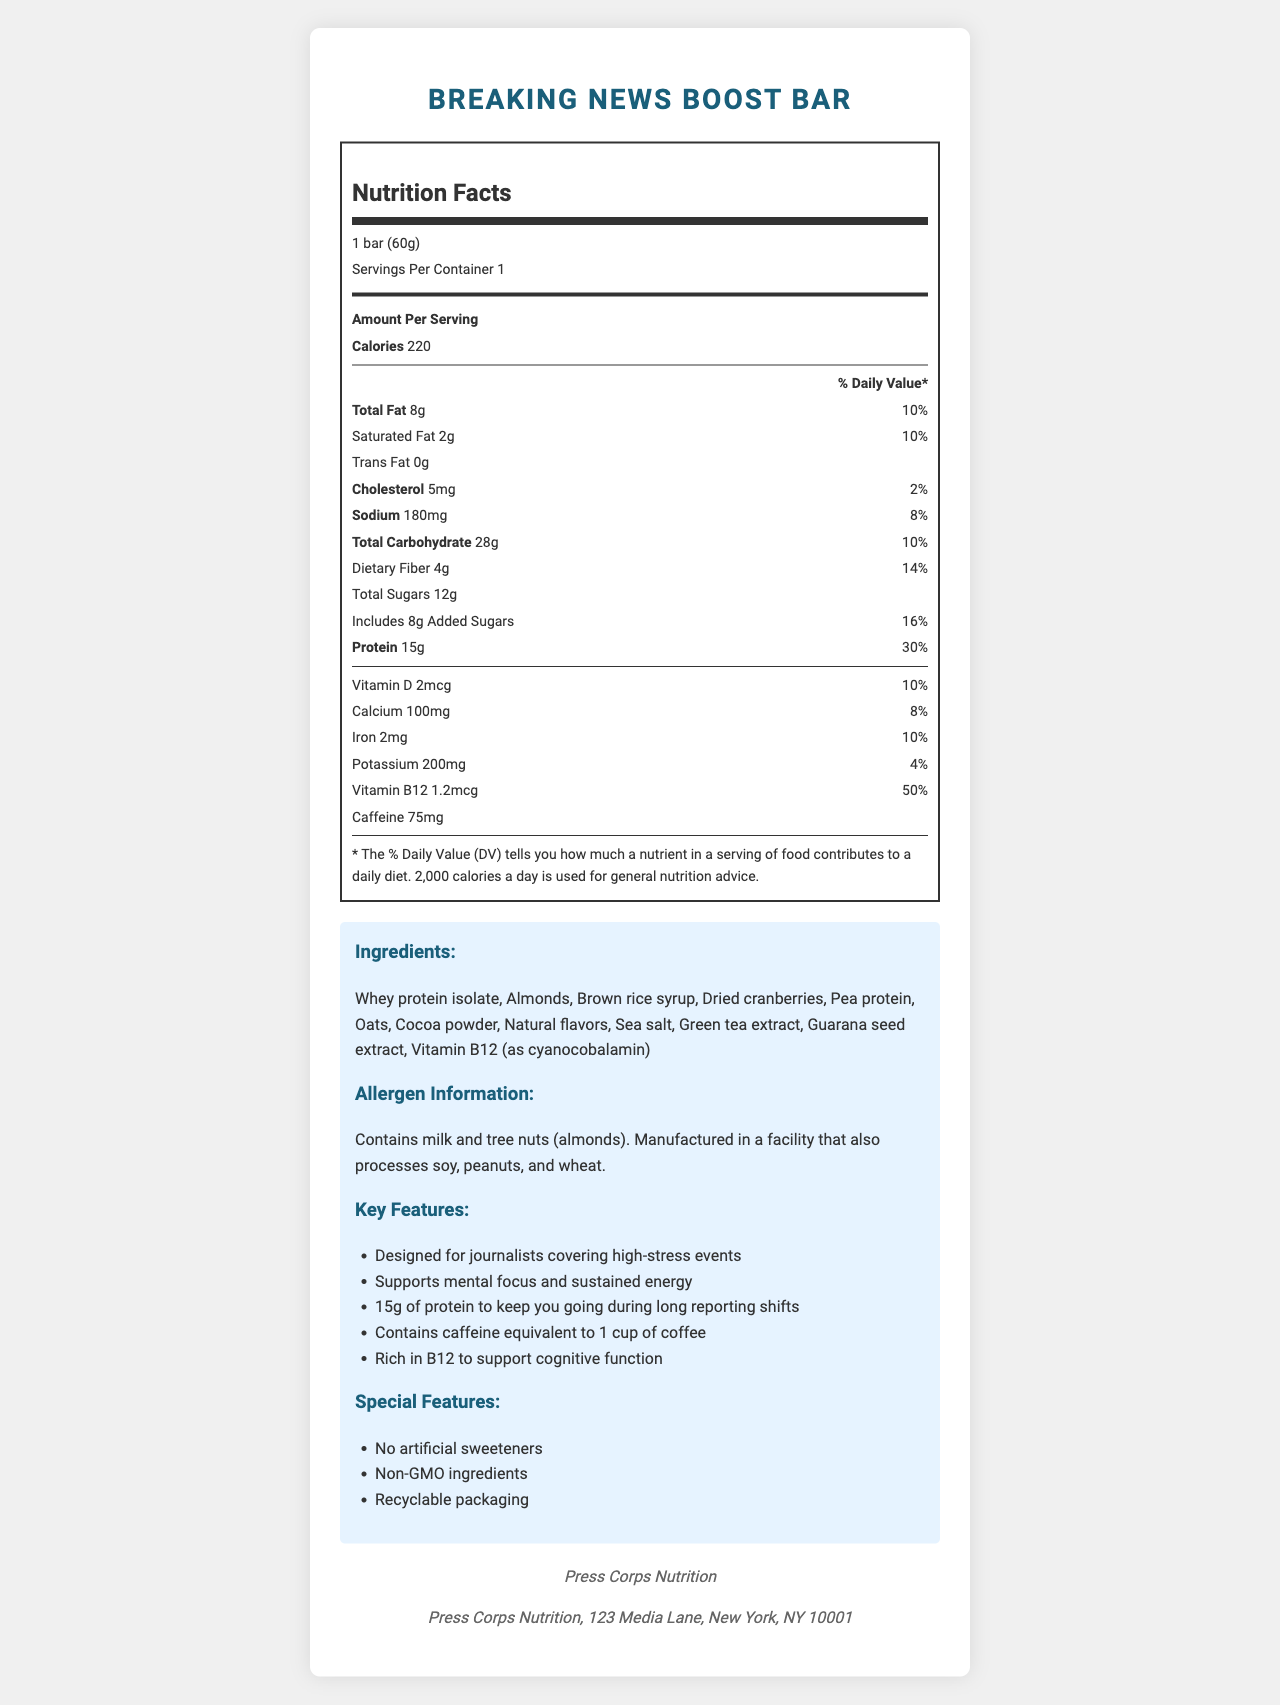what is the serving size of the Breaking News Boost Bar? The serving size is listed at the top of the Nutrition Facts section as "1 bar (60g)".
Answer: 1 bar (60g) how many calories are there per serving? The calories per serving are indicated in the Amount Per Serving section as "Calories 220".
Answer: 220 what percentage of the daily value for protein does one bar provide? The percentage of the daily value for protein is listed next to the protein content in the Nutrition Facts section as "30%".
Answer: 30% how many grams of dietary fiber are in one serving? The dietary fiber content is listed in the Nutrition Facts section under Total Carbohydrate, stated as "Dietary Fiber 4g".
Answer: 4g what is the main source of caffeine in this bar? Under the ingredients list, both "Green tea extract" and "Guarana seed extract" provide caffeine.
Answer: Green tea extract and guarana seed extract what are the primary allergens contained in the bar? The Allergen Information section lists "Contains milk and tree nuts (almonds)".
Answer: Milk and tree nuts (almonds) how many grams of total sugars are in one serving of the bar? The total sugars content is listed under Total Carbohydrate in the Nutrition Facts section as "Total Sugars 12g".
Answer: 12g what is the purpose of adding Vitamin B12 to the bar? A. To boost protein content B. To support heart health C. To support cognitive function D. To improve digestion One of the claim statements explicitly says that the bar is "Rich in B12 to support cognitive function".
Answer: C how much caffeine does this bar contain? A. 50mg B. 60mg C. 75mg D. 100mg Under the Nutrition Facts section, it states "Caffeine 75mg".
Answer: C is the Breaking News Boost Bar suitable for someone following a non-GMO diet? (Yes/No) One of the special features listed is "Non-GMO ingredients".
Answer: Yes does this product contain any artificial sweeteners? (True/False) One of the special features states "No artificial sweeteners".
Answer: False summarize the main features and nutritional benefits of the Breaking News Boost Bar This summary covers all the main features, claim statements, and key nutritional information from the label.
Answer: The Breaking News Boost Bar is designed specifically for journalists covering high-stress events. It contains 220 calories per bar, 15g of protein, and 75mg of caffeine. It also includes important nutrients like Vitamin B12, which supports cognitive function, and is rich in dietary fiber. The bar is made with non-GMO ingredients, contains no artificial sweeteners, and has recyclable packaging. Allergen information notes that it contains milk and tree nuts. what is the country of manufacture for the Breaking News Boost Bar? The document does not mention the country of manufacture; it only provides the company address which is located in New York, NY.
Answer: Cannot be determined what percentage of the daily value of calcium does one bar provide? The Nutrition Facts section lists the daily value percentage for calcium as "8%".
Answer: 8% 